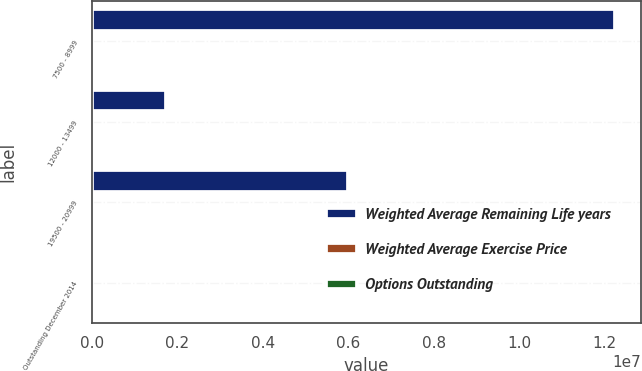<chart> <loc_0><loc_0><loc_500><loc_500><stacked_bar_chart><ecel><fcel>7500 - 8999<fcel>12000 - 13499<fcel>19500 - 20999<fcel>Outstanding December 2014<nl><fcel>Weighted Average Remaining Life years<fcel>1.22363e+07<fcel>1.73795e+06<fcel>5.98112e+06<fcel>120.4<nl><fcel>Weighted Average Exercise Price<fcel>78.78<fcel>131.64<fcel>202.27<fcel>120.4<nl><fcel>Options Outstanding<fcel>4<fcel>0.92<fcel>2.48<fcel>3.28<nl></chart> 